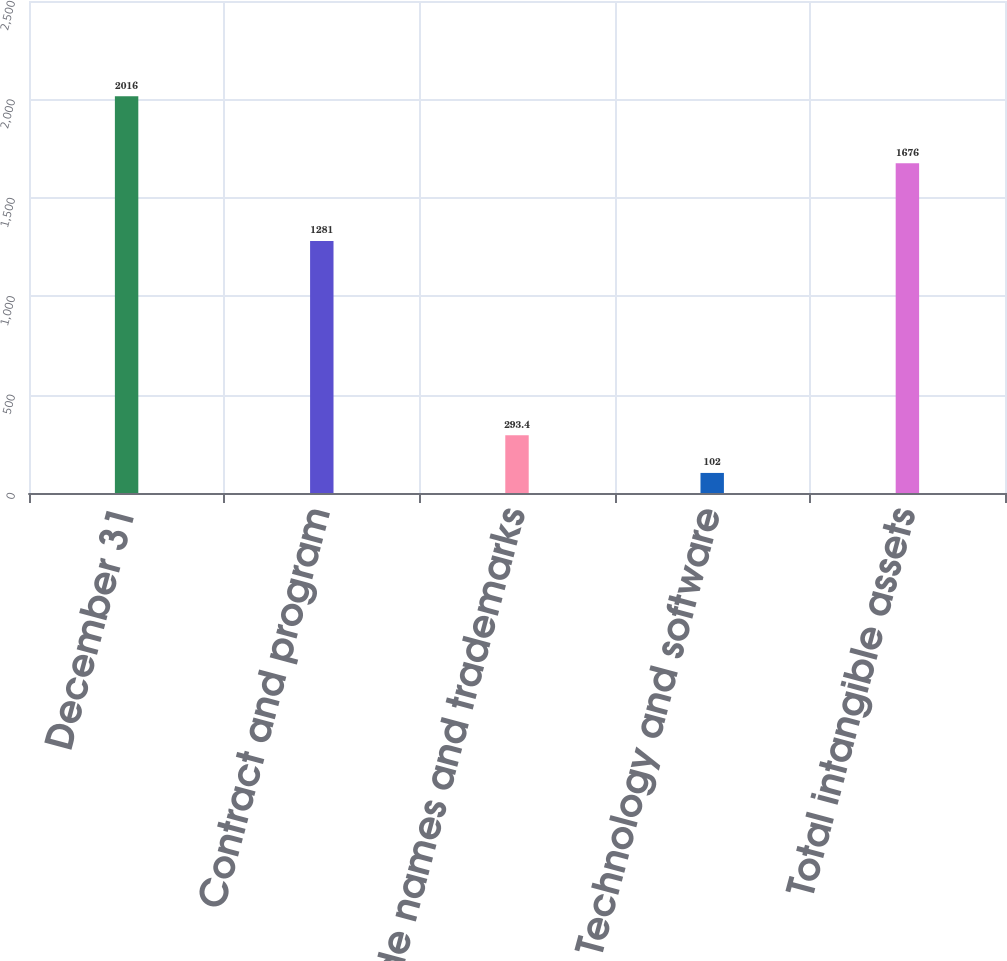Convert chart to OTSL. <chart><loc_0><loc_0><loc_500><loc_500><bar_chart><fcel>December 31<fcel>Contract and program<fcel>Trade names and trademarks<fcel>Technology and software<fcel>Total intangible assets<nl><fcel>2016<fcel>1281<fcel>293.4<fcel>102<fcel>1676<nl></chart> 